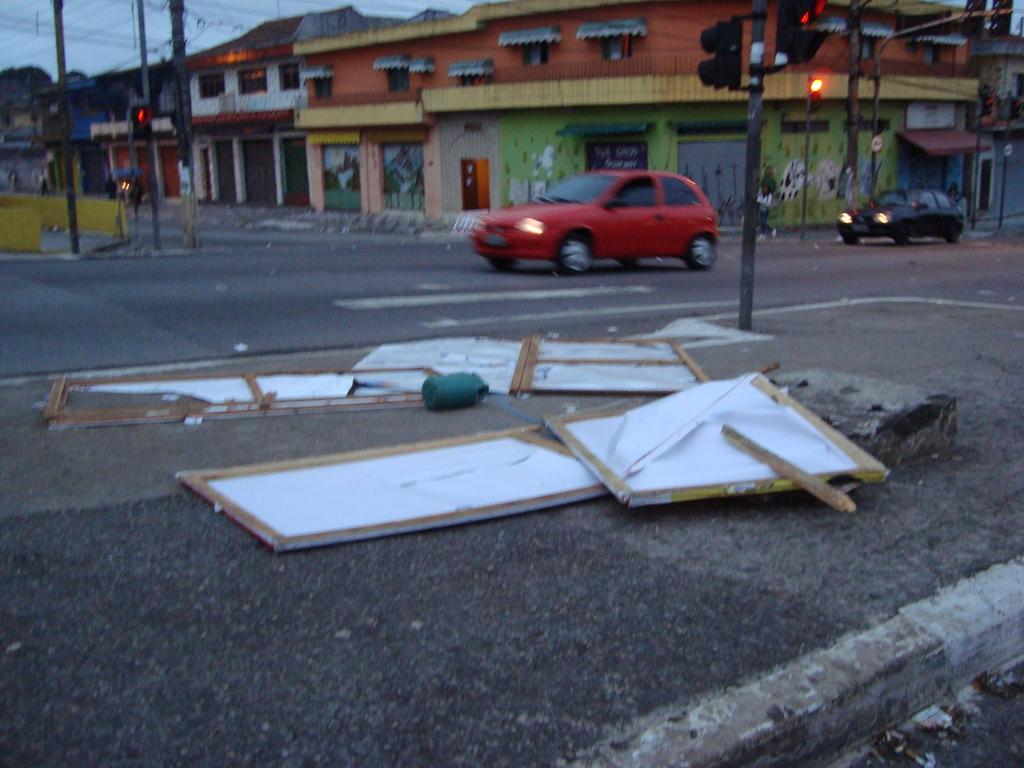Who or what can be seen in the image? There are people in the image. What else is visible on the road in the image? There are cars on the road in the image. What structures are present along the road in the image? There are light poles and traffic lights in the image. What objects are on the ground in the image? There are boards on the ground in the image. What type of buildings can be seen in the image? There are houses in the image. What part of the natural environment is visible in the image? The sky is visible in the image. Can you tell me how many socks are hanging from the light poles in the image? There are no socks present in the image; only light poles, traffic lights, and other objects related to the road and buildings can be seen. 